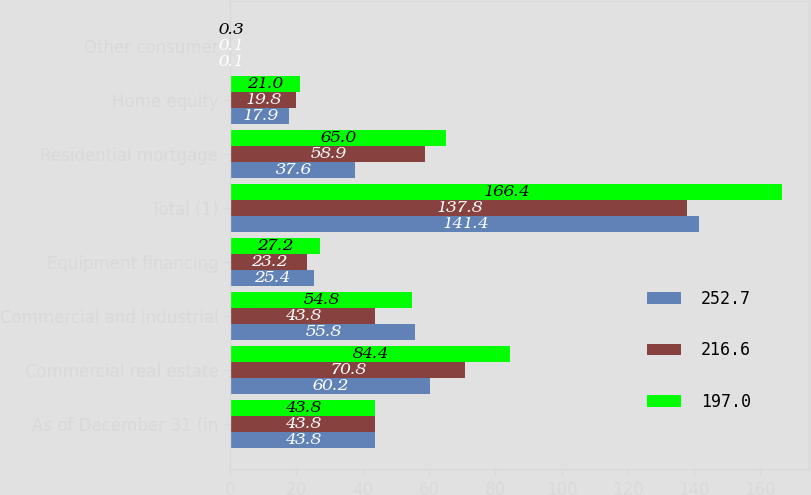<chart> <loc_0><loc_0><loc_500><loc_500><stacked_bar_chart><ecel><fcel>As of December 31 (in<fcel>Commercial real estate<fcel>Commercial and industrial<fcel>Equipment financing<fcel>Total (1)<fcel>Residential mortgage<fcel>Home equity<fcel>Other consumer<nl><fcel>252.7<fcel>43.8<fcel>60.2<fcel>55.8<fcel>25.4<fcel>141.4<fcel>37.6<fcel>17.9<fcel>0.1<nl><fcel>216.6<fcel>43.8<fcel>70.8<fcel>43.8<fcel>23.2<fcel>137.8<fcel>58.9<fcel>19.8<fcel>0.1<nl><fcel>197<fcel>43.8<fcel>84.4<fcel>54.8<fcel>27.2<fcel>166.4<fcel>65<fcel>21<fcel>0.3<nl></chart> 